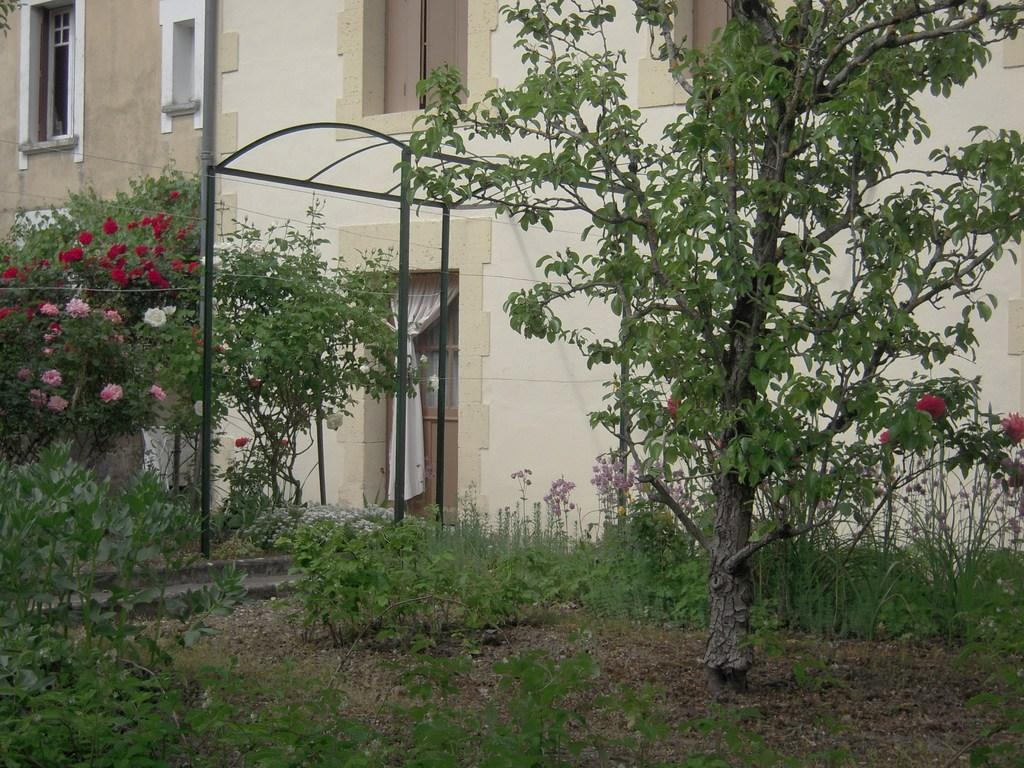What type of structures can be seen in the image? There are buildings in the image. What other natural elements are present in the image? There are trees in the image. Can you describe any man-made objects in the image? There is a curtain visible in the image. What type of vegetation is on the ground in the image? There are plants on the ground in the image. What additional features can be observed on the trees in the image? Flowers are present on the trees in the image. What type of cushion is being used to support the meal in the image? There is no cushion or meal present in the image. What hope can be seen in the image? The concept of hope is abstract and cannot be seen in the image. 